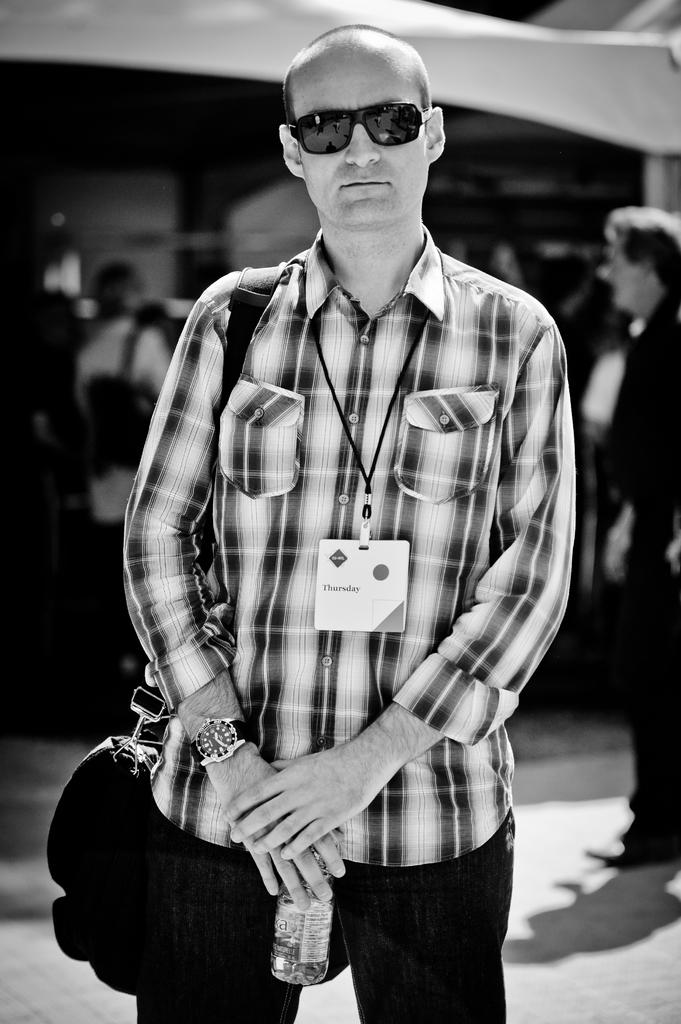What is the main subject of the image? There is a person in the image. What is the person wearing in the image? The person is wearing a bag. What is the person holding in the image? The person is holding a bottle. How would you describe the background of the image? The background of the image is blurred. What is the color scheme of the image? The image is in black and white. What downtown area is depicted in the image? There is no downtown area depicted in the image, as it only features a person wearing a bag and holding a bottle. 